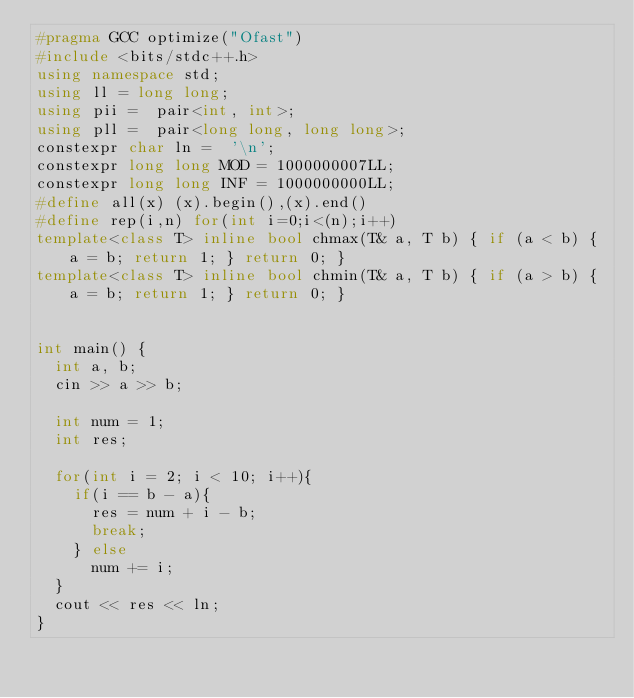<code> <loc_0><loc_0><loc_500><loc_500><_C++_>#pragma GCC optimize("Ofast")
#include <bits/stdc++.h>
using namespace std;
using ll = long long;
using pii =  pair<int, int>;
using pll =  pair<long long, long long>;
constexpr char ln =  '\n';
constexpr long long MOD = 1000000007LL;
constexpr long long INF = 1000000000LL;
#define all(x) (x).begin(),(x).end()
#define rep(i,n) for(int i=0;i<(n);i++)
template<class T> inline bool chmax(T& a, T b) { if (a < b) { a = b; return 1; } return 0; }
template<class T> inline bool chmin(T& a, T b) { if (a > b) { a = b; return 1; } return 0; }


int main() {
  int a, b;
  cin >> a >> b;

  int num = 1;
  int res;

  for(int i = 2; i < 10; i++){
    if(i == b - a){
      res = num + i - b;
      break;
    } else
      num += i;  
  }
  cout << res << ln;
}
  
</code> 